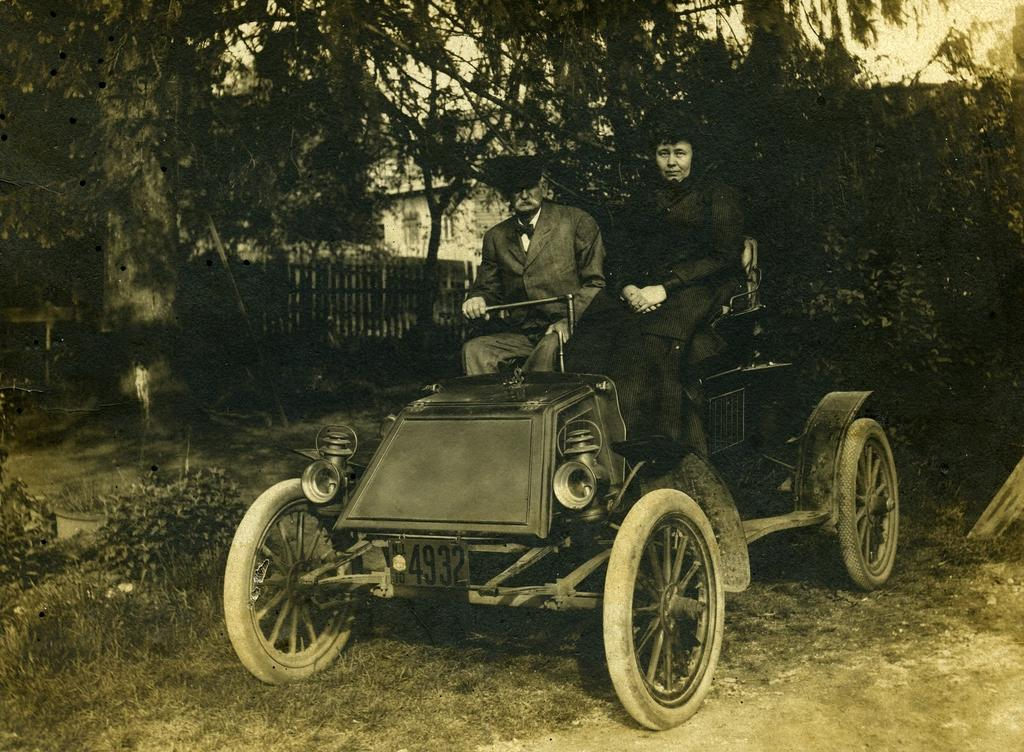How many people are in the image? There are two people in the image. What are the people doing in the image? The people are sitting on an old car. Can you describe the car in the image? The car has a number 4932. Where was the image taken? The image was clicked inside a lawn. What can be seen in the background of the image? There are trees and buildings in the background of the image. What type of bath can be seen in the image? There is no bath present in the image. Is the father of the people in the image also visible? The facts provided do not mention a father, so it cannot be determined if the father is visible in the image. 